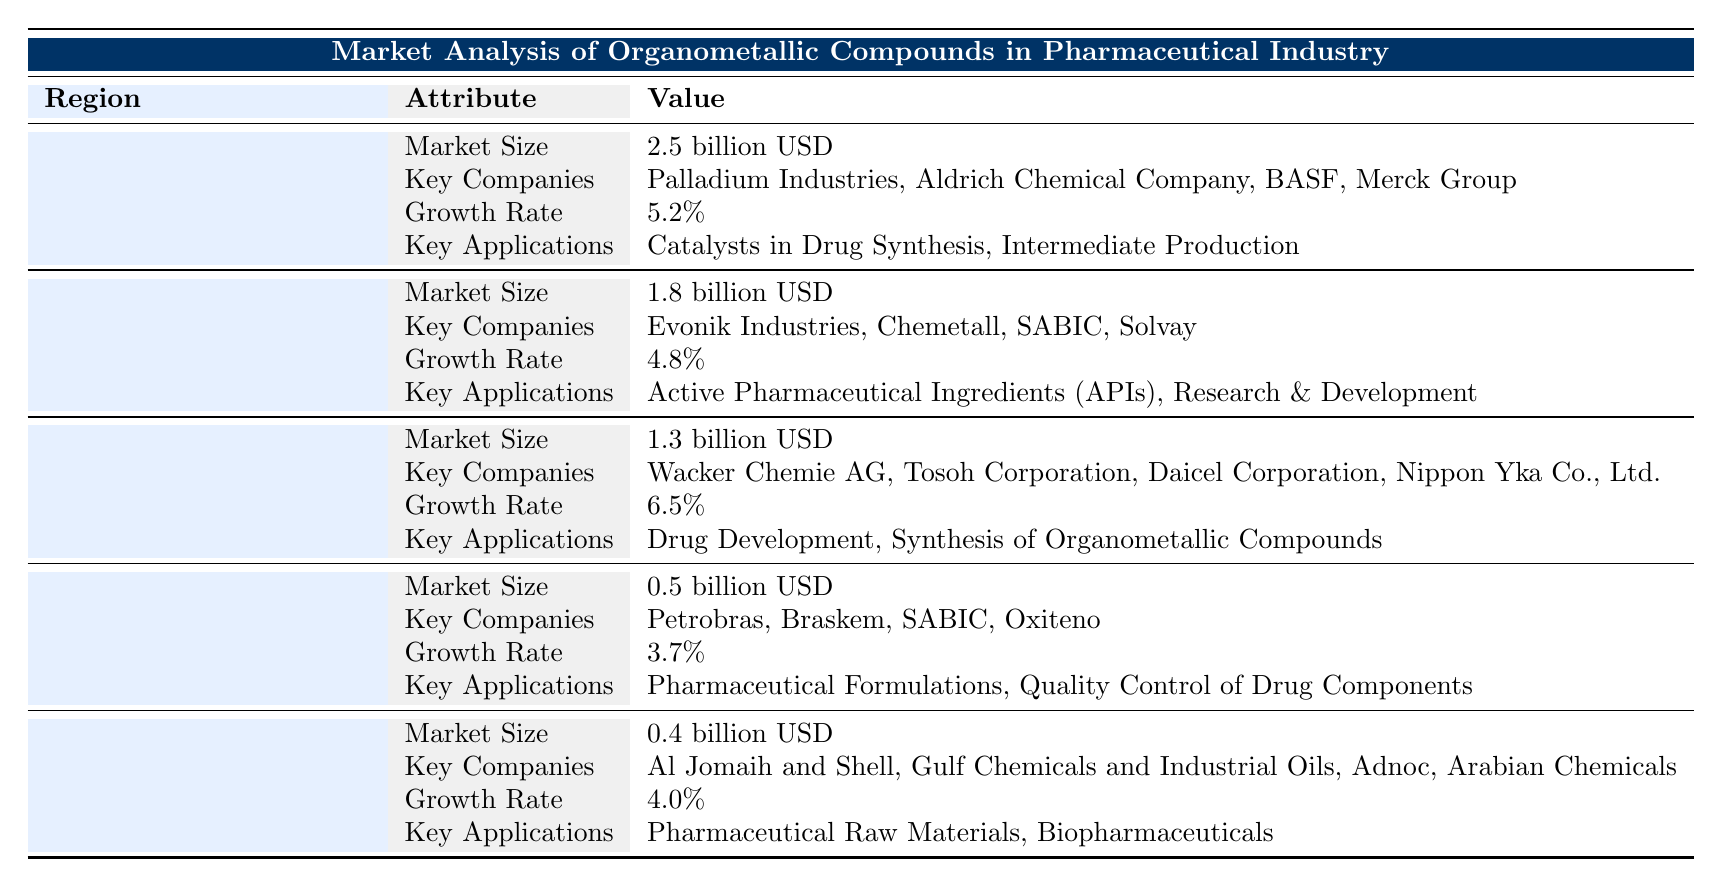What is the market size for organometallic compounds in North America? The table indicates that the market size for North America is specified directly as "2.5 billion USD."
Answer: 2.5 billion USD Which region has the highest growth rate for organometallic compounds in the pharmaceutical industry? Looking at the growth rates provided in the table, Asia Pacific has the highest growth rate at "6.5%."
Answer: Asia Pacific Are there any key companies listed for the Middle East and Africa region? The table lists four key companies for the Middle East and Africa: "Al Jomaih and Shell, Gulf Chemicals and Industrial Oils, Adnoc, Arabian Chemicals," which confirms the presence of key companies for this region.
Answer: Yes What is the total market size for organometallic compounds in Europe and Latin America combined? The market size for Europe is "1.8 billion USD" and for Latin America it is "0.5 billion USD." Adding these together gives: 1.8 + 0.5 = 2.3 billion USD.
Answer: 2.3 billion USD Is "Quality Control of Drug Components" mentioned as a key application in any region? According to the table, "Quality Control of Drug Components" is listed as a key application specifically in the Latin America region.
Answer: Yes Which region has the lowest market size for organometallic compounds? The table shows that the Middle East and Africa has the lowest market size at "0.4 billion USD," compared to other regions.
Answer: Middle East and Africa What is the average growth rate of the organometallic market across all listed regions? The growth rates are: 5.2% (North America), 4.8% (Europe), 6.5% (Asia Pacific), 3.7% (Latin America), and 4.0% (Middle East and Africa). First, sum these growth rates: 5.2 + 4.8 + 6.5 + 3.7 + 4.0 = 24.2%. Then divide by the number of regions: 24.2 / 5 = 4.84%.
Answer: 4.84% What are two key applications in Asia Pacific for organometallic compounds? The table clearly states that the two key applications in the Asia Pacific region are "Drug Development" and "Synthesis of Organometallic Compounds."
Answer: Drug Development, Synthesis of Organometallic Compounds Is BASF a key company in the European market for organometallic compounds? The table lists the key companies in Europe, which include "Evonik Industries, Chemetall, SABIC, Solvay," and does not mention BASF, indicating it is not a key company in this region.
Answer: No 